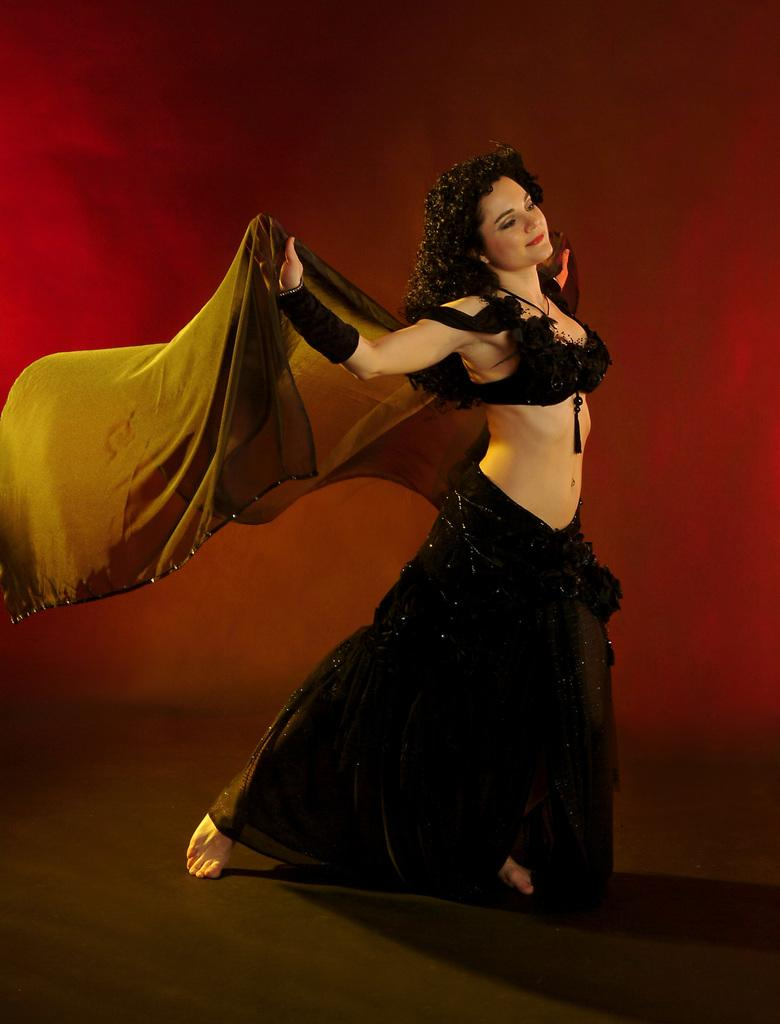Who is the main subject in the image? There is a woman in the image. What is the woman wearing? The woman is wearing a black dress. What is the color of the surface on which the image is displayed? The image has a black surface. What color is the background of the image? The background of the image is red. What type of iron can be seen in the image? There is no iron present in the image. What toys are visible in the image? There are no toys visible in the image. 